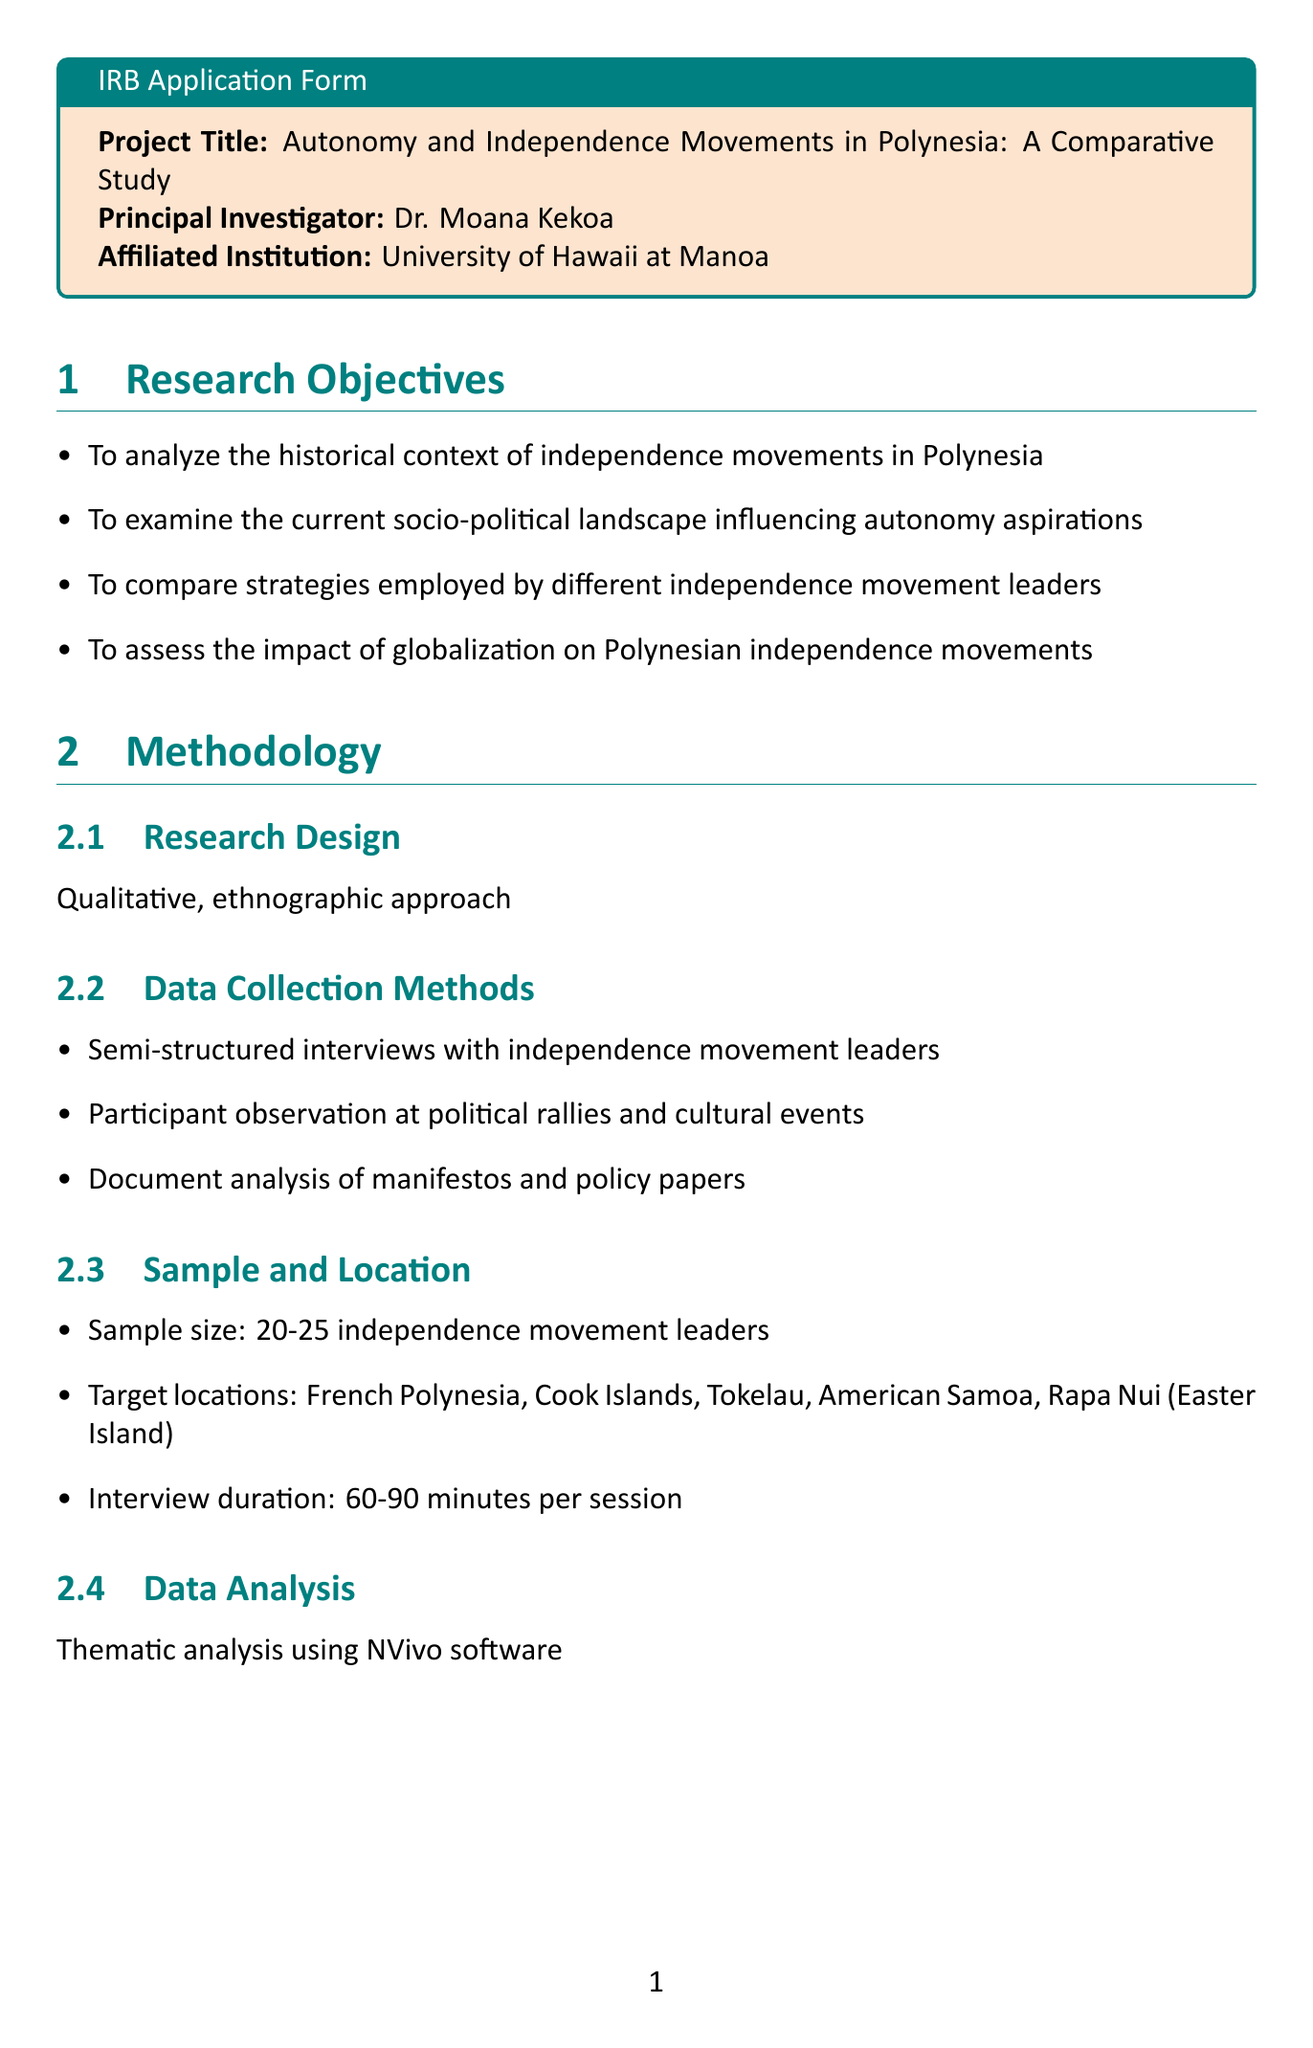What is the project title? The project title is the main focus of the research, which is detailed in the document.
Answer: Autonomy and Independence Movements in Polynesia: A Comparative Study Who is the principal investigator? The principal investigator is the individual leading the research project.
Answer: Dr. Moana Kekoa What is the sample size for the study? The sample size refers to the number of participants targeted for interviews outlined in the methodology section.
Answer: 20-25 independence movement leaders What are the target locations for the research? The target locations indicate where the fieldwork will take place and are listed in the methodology.
Answer: French Polynesia, Cook Islands, Tokelau, American Samoa, Rapa Nui (Easter Island) What is a potential risk mentioned in the document? This identifies potential issues that could arise during the research, as highlighted in the risk assessment section.
Answer: Political sensitivity of the topic What analysis method will be used for the data? This specifies the technique for interpreting the collected data described in the methodology.
Answer: Thematic analysis using NVivo software During what period will the fieldwork take place? This provides specific dates for when the fieldwork is scheduled to occur, mentioned in the timeline section.
Answer: March 2024 - November 2024 What measures are in place to ensure confidentiality? This refers to the strategies employed to protect participant information detailed in the participant protection section.
Answer: Use of pseudonyms in all research outputs What is the funding source for the project? The funding source indicates who financially supports the research project, as specified in the document.
Answer: National Science Foundation - Political Science Program 